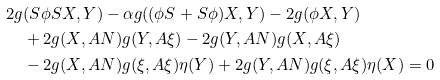Convert formula to latex. <formula><loc_0><loc_0><loc_500><loc_500>& 2 g ( S \phi S X , Y ) - \alpha g ( ( \phi S + S \phi ) X , Y ) - 2 g ( \phi X , Y ) \\ & \quad + 2 g ( X , A N ) g ( Y , A \xi ) - 2 g ( Y , A N ) g ( X , A \xi ) \\ & \quad - 2 g ( X , A N ) g ( \xi , A \xi ) \eta ( Y ) + 2 g ( Y , A N ) g ( \xi , A \xi ) \eta ( X ) = 0</formula> 